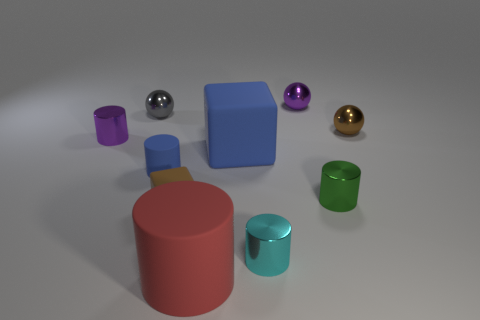There is a shiny sphere on the left side of the blue rubber cylinder; does it have the same size as the large blue object?
Your answer should be compact. No. What number of big objects are balls or red rubber cylinders?
Ensure brevity in your answer.  1. Are there any things that have the same color as the large matte cube?
Your response must be concise. Yes. What shape is the purple metallic object that is the same size as the purple metal cylinder?
Keep it short and to the point. Sphere. There is a metallic ball that is in front of the gray metal object; is its color the same as the tiny rubber block?
Ensure brevity in your answer.  Yes. What number of things are either tiny cylinders that are on the left side of the big cylinder or red cylinders?
Offer a very short reply. 3. Are there more tiny green cylinders that are in front of the small green thing than blue rubber blocks behind the small block?
Offer a terse response. No. Does the gray sphere have the same material as the big blue thing?
Your answer should be compact. No. The small thing that is in front of the tiny green shiny cylinder and behind the tiny cyan metallic object has what shape?
Ensure brevity in your answer.  Cube. There is a small brown object that is the same material as the small cyan object; what is its shape?
Offer a terse response. Sphere. 